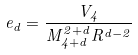<formula> <loc_0><loc_0><loc_500><loc_500>\ e _ { d } = \frac { V _ { 4 } } { M _ { 4 + d } ^ { 2 + d } R ^ { d - 2 } }</formula> 